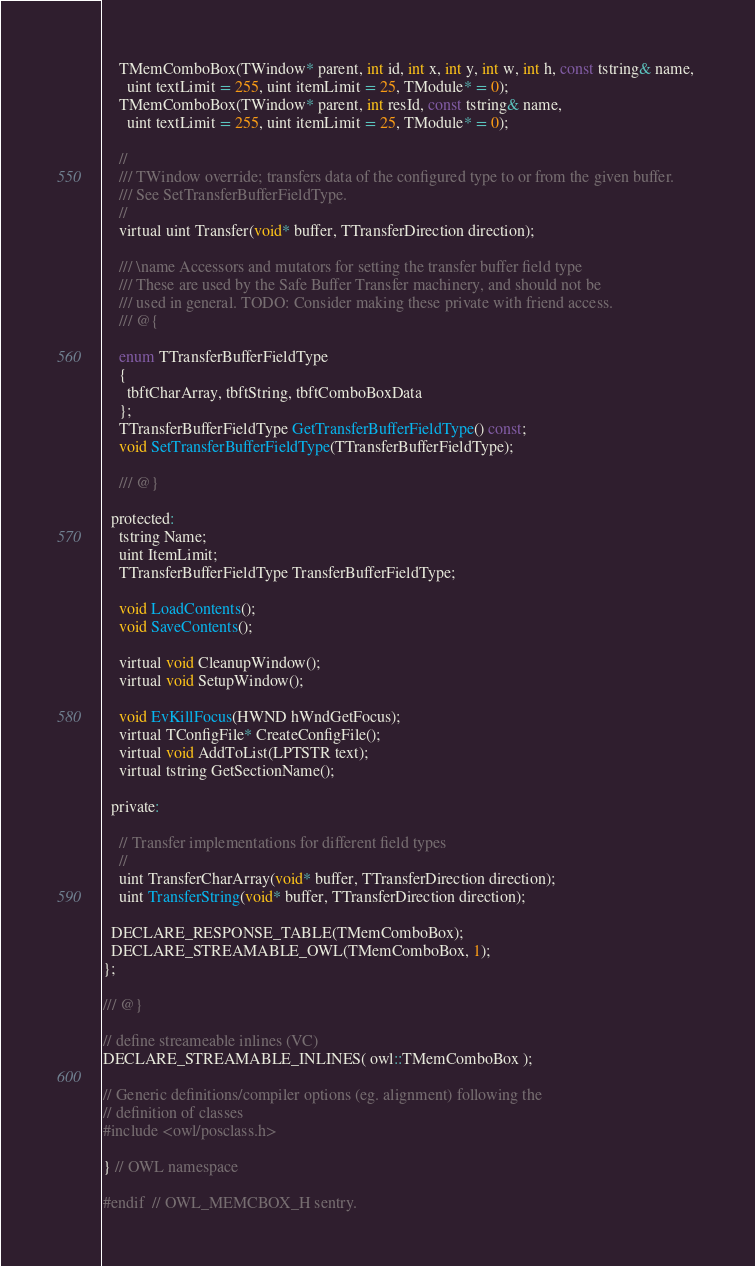Convert code to text. <code><loc_0><loc_0><loc_500><loc_500><_C_>    TMemComboBox(TWindow* parent, int id, int x, int y, int w, int h, const tstring& name, 
      uint textLimit = 255, uint itemLimit = 25, TModule* = 0);
    TMemComboBox(TWindow* parent, int resId, const tstring& name, 
      uint textLimit = 255, uint itemLimit = 25, TModule* = 0);
  
    //
    /// TWindow override; transfers data of the configured type to or from the given buffer.
    /// See SetTransferBufferFieldType.
    //
    virtual uint Transfer(void* buffer, TTransferDirection direction);

    /// \name Accessors and mutators for setting the transfer buffer field type
    /// These are used by the Safe Buffer Transfer machinery, and should not be
    /// used in general. TODO: Consider making these private with friend access.
    /// @{

    enum TTransferBufferFieldType
    {
      tbftCharArray, tbftString, tbftComboBoxData
    };
    TTransferBufferFieldType GetTransferBufferFieldType() const;
    void SetTransferBufferFieldType(TTransferBufferFieldType);

    /// @}

  protected:
    tstring Name;
    uint ItemLimit;
    TTransferBufferFieldType TransferBufferFieldType;

    void LoadContents();
    void SaveContents();

    virtual void CleanupWindow();
    virtual void SetupWindow();

    void EvKillFocus(HWND hWndGetFocus);
    virtual TConfigFile* CreateConfigFile();
    virtual void AddToList(LPTSTR text);
    virtual tstring GetSectionName();

  private:

    // Transfer implementations for different field types
    //
    uint TransferCharArray(void* buffer, TTransferDirection direction);
    uint TransferString(void* buffer, TTransferDirection direction);

  DECLARE_RESPONSE_TABLE(TMemComboBox);
  DECLARE_STREAMABLE_OWL(TMemComboBox, 1);
}; 

/// @}

// define streameable inlines (VC)
DECLARE_STREAMABLE_INLINES( owl::TMemComboBox );

// Generic definitions/compiler options (eg. alignment) following the
// definition of classes
#include <owl/posclass.h>

} // OWL namespace

#endif  // OWL_MEMCBOX_H sentry.

</code> 